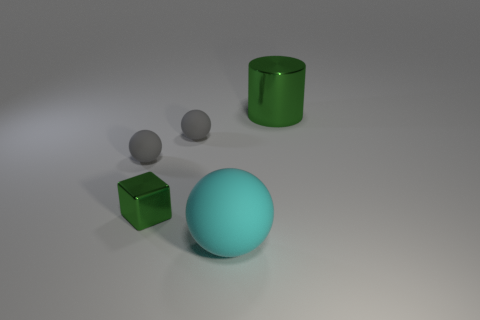Subtract all small matte spheres. How many spheres are left? 1 Add 2 small metallic things. How many objects exist? 7 Subtract all spheres. How many objects are left? 2 Add 3 big cyan rubber spheres. How many big cyan rubber spheres exist? 4 Subtract 0 brown cubes. How many objects are left? 5 Subtract all large shiny things. Subtract all green metal objects. How many objects are left? 2 Add 2 small matte objects. How many small matte objects are left? 4 